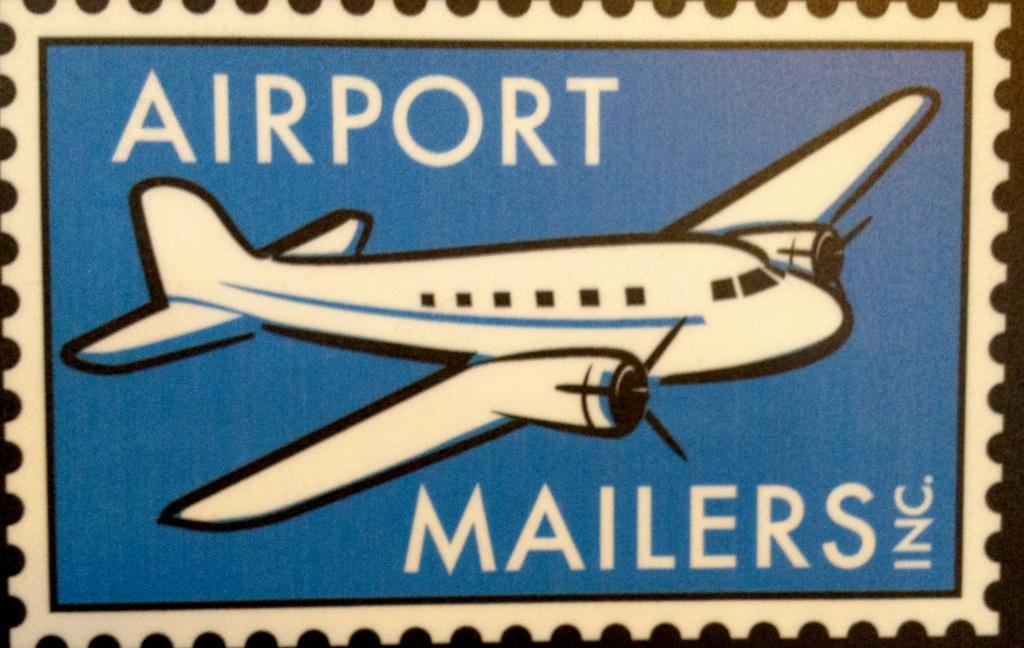Please provide a concise description of this image. In the foreground of this poster, there is an image of aeroplane and some text on the top and bottom. 